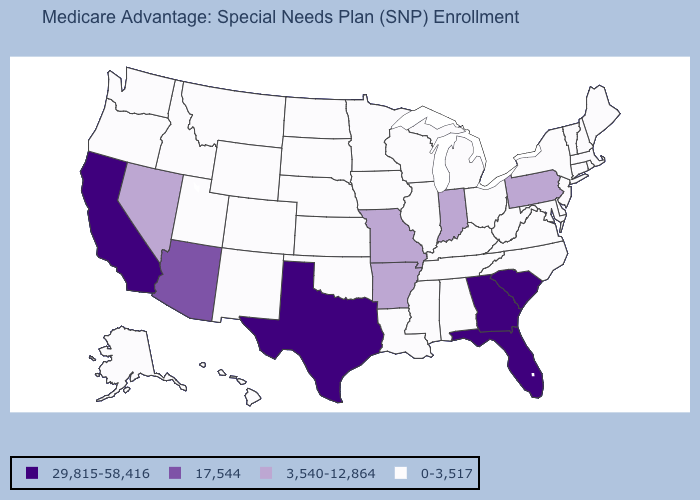Name the states that have a value in the range 29,815-58,416?
Short answer required. California, Florida, Georgia, South Carolina, Texas. Which states have the lowest value in the USA?
Concise answer only. Alaska, Alabama, Colorado, Connecticut, Delaware, Hawaii, Iowa, Idaho, Illinois, Kansas, Kentucky, Louisiana, Massachusetts, Maryland, Maine, Michigan, Minnesota, Mississippi, Montana, North Carolina, North Dakota, Nebraska, New Hampshire, New Jersey, New Mexico, New York, Ohio, Oklahoma, Oregon, Rhode Island, South Dakota, Tennessee, Utah, Virginia, Vermont, Washington, Wisconsin, West Virginia, Wyoming. Name the states that have a value in the range 0-3,517?
Write a very short answer. Alaska, Alabama, Colorado, Connecticut, Delaware, Hawaii, Iowa, Idaho, Illinois, Kansas, Kentucky, Louisiana, Massachusetts, Maryland, Maine, Michigan, Minnesota, Mississippi, Montana, North Carolina, North Dakota, Nebraska, New Hampshire, New Jersey, New Mexico, New York, Ohio, Oklahoma, Oregon, Rhode Island, South Dakota, Tennessee, Utah, Virginia, Vermont, Washington, Wisconsin, West Virginia, Wyoming. What is the value of Kansas?
Give a very brief answer. 0-3,517. Which states hav the highest value in the Northeast?
Concise answer only. Pennsylvania. Does South Dakota have a lower value than Oklahoma?
Quick response, please. No. What is the value of Utah?
Keep it brief. 0-3,517. Which states have the highest value in the USA?
Give a very brief answer. California, Florida, Georgia, South Carolina, Texas. Name the states that have a value in the range 17,544?
Keep it brief. Arizona. What is the lowest value in the USA?
Be succinct. 0-3,517. Does Michigan have the lowest value in the USA?
Keep it brief. Yes. How many symbols are there in the legend?
Quick response, please. 4. Which states have the lowest value in the USA?
Quick response, please. Alaska, Alabama, Colorado, Connecticut, Delaware, Hawaii, Iowa, Idaho, Illinois, Kansas, Kentucky, Louisiana, Massachusetts, Maryland, Maine, Michigan, Minnesota, Mississippi, Montana, North Carolina, North Dakota, Nebraska, New Hampshire, New Jersey, New Mexico, New York, Ohio, Oklahoma, Oregon, Rhode Island, South Dakota, Tennessee, Utah, Virginia, Vermont, Washington, Wisconsin, West Virginia, Wyoming. What is the value of Montana?
Short answer required. 0-3,517. 